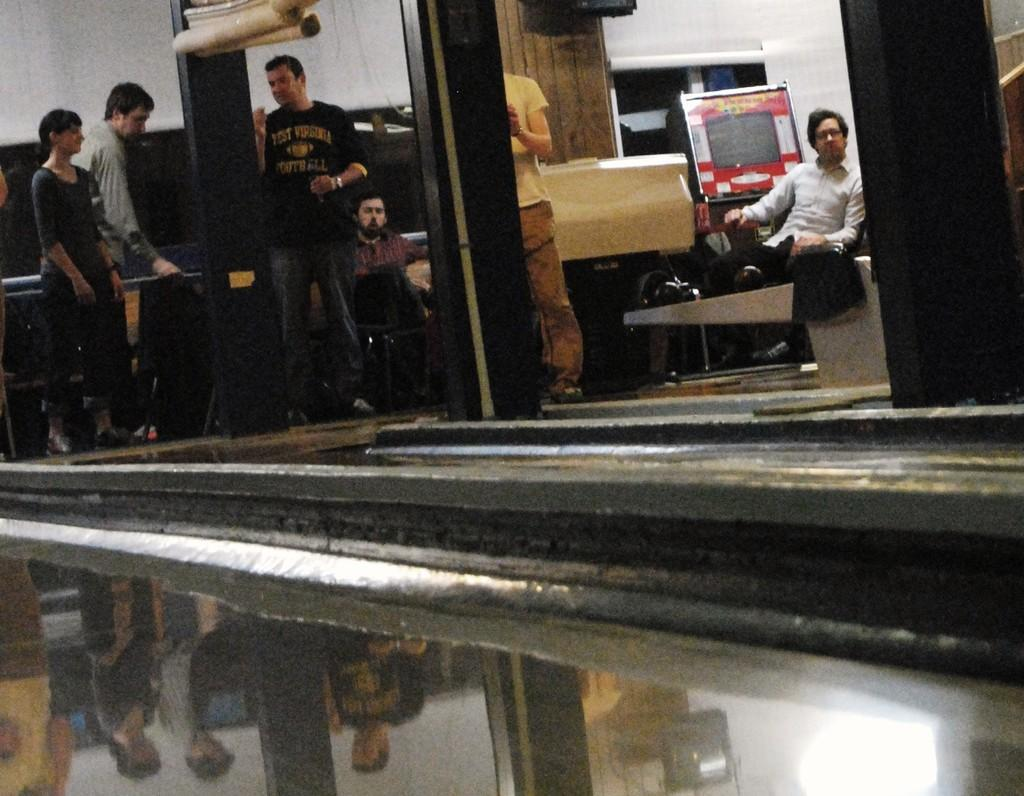What object is located in the foreground of the image? There is a glass in the foreground of the image. What can be seen in the background of the image? There are persons, a board, a wall, a glass window, and pillars in the background of the image. Can you describe the board in the background? Unfortunately, the facts provided do not give any details about the board, so we cannot describe it further. How many clocks are hanging on the wall in the image? There is no mention of clocks in the provided facts, so we cannot determine the number of clocks in the image. What type of drink is being served in the glass in the image? The facts provided do not specify the contents of the glass, so we cannot determine what type of drink is being served. 